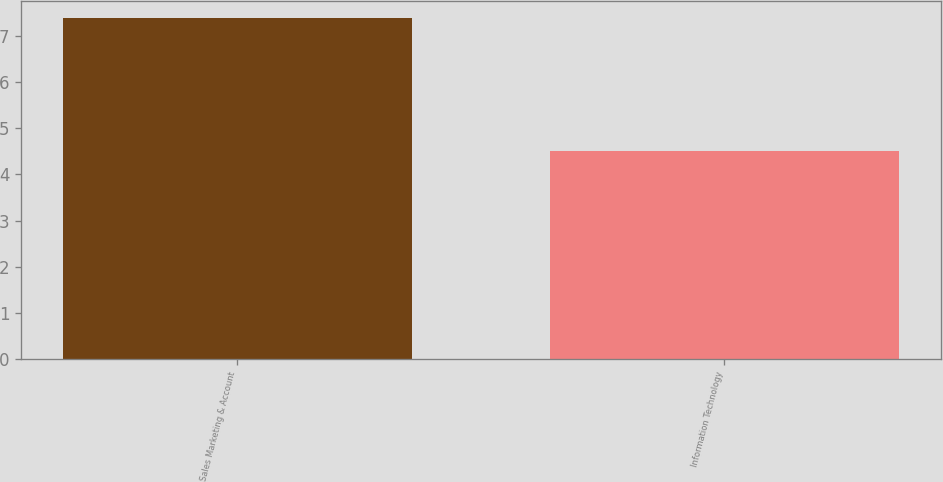<chart> <loc_0><loc_0><loc_500><loc_500><bar_chart><fcel>Sales Marketing & Account<fcel>Information Technology<nl><fcel>7.4<fcel>4.5<nl></chart> 